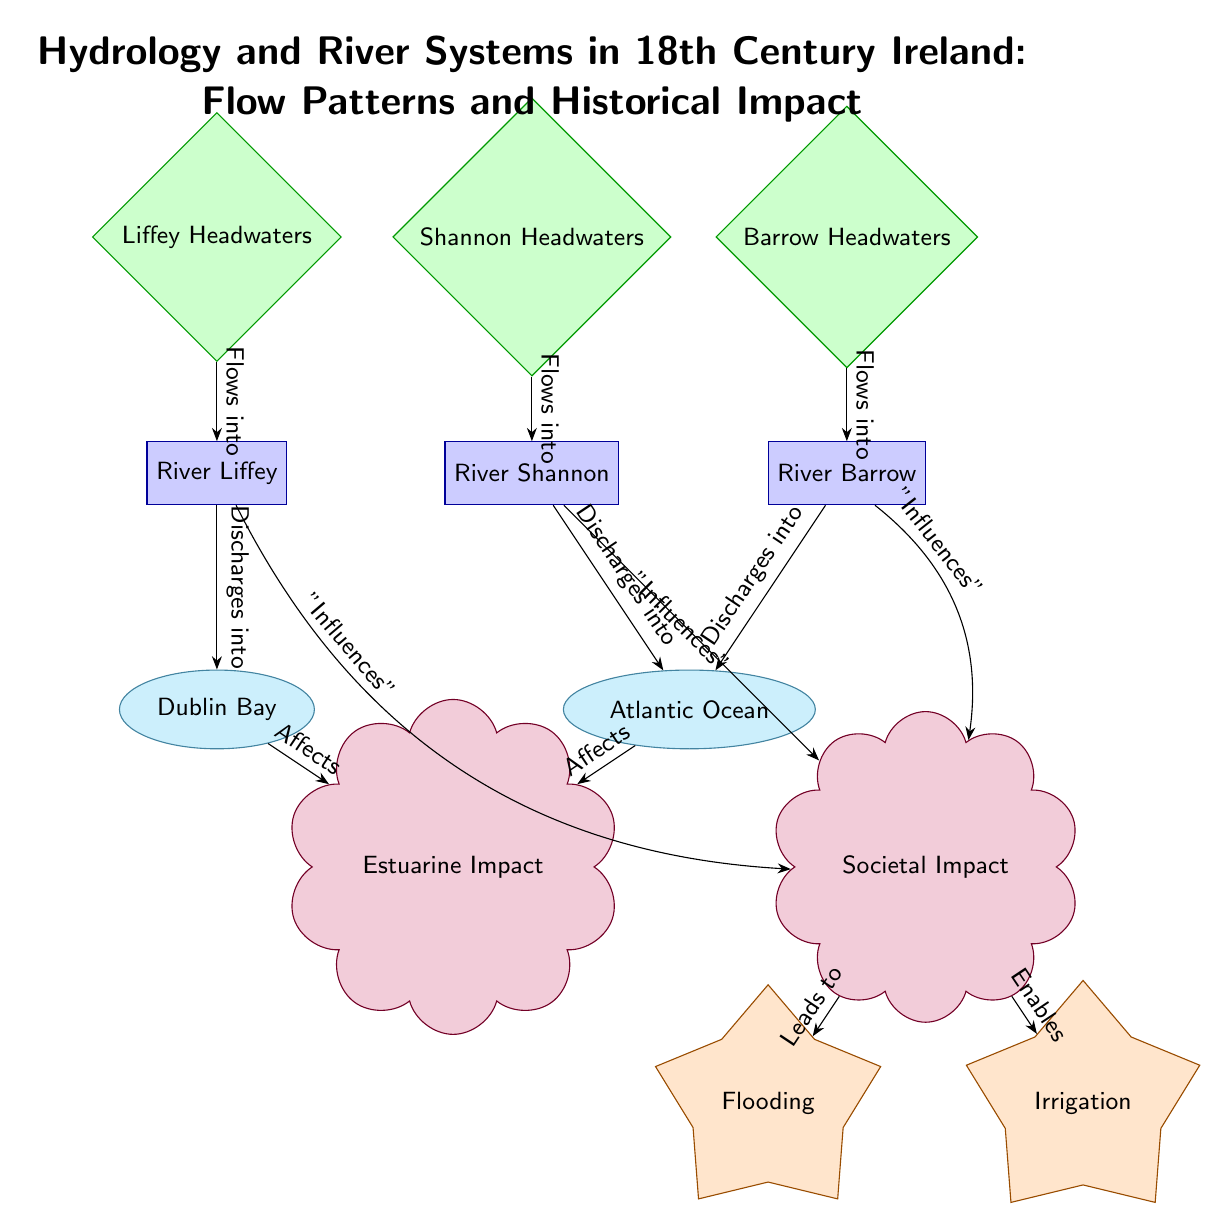What are the headwaters of the rivers depicted in the diagram? The diagram lists three headwaters: Liffey Headwaters, Shannon Headwaters, and Barrow Headwaters, which are shown as source nodes above the river nodes.
Answer: Liffey Headwaters, Shannon Headwaters, Barrow Headwaters How many rivers are included in the diagram? The diagram features three rivers: River Liffey, River Shannon, and River Barrow, indicated as river nodes.
Answer: Three Which outflow connects to Dublin Bay? The diagram shows that the River Liffey discharges into Dublin Bay, indicated by an edge pointing from Liffey River to Dublin Bay.
Answer: River Liffey What impact do the rivers have on society according to the diagram? The diagram illustrates that the rivers influence societal impact, as indicated by edges pointing towards the societal impact node and labeled "Influences."
Answer: Societal Impact How does societal impact lead to flooding? The diagram indicates that there is an edge leading from the societal impact node to the flooding phenomenon node, labeled "Leads to," which shows that societal impacts can result in flooding.
Answer: Leads to Which river discharges into the Atlantic Ocean? Both the River Shannon and River Barrow discharge into the Atlantic Ocean, as per the edges displaying this discharging relationship.
Answer: River Shannon, River Barrow What are the two identified phenomena related to the impacts in the diagram? The diagram mentions two phenomena resulting from societal impact: flooding and irrigation, shown as distinct nodes below societal impact.
Answer: Flooding, Irrigation Which body of water affects estuarine impact? The diagram illustrates that both Dublin Bay and the Atlantic Ocean affect estuarine impact, indicated by reciprocal edges pointing to the estuarine impact node.
Answer: Dublin Bay, Atlantic Ocean How many edges connect to societal impact? There are three edges connecting to societal impact: from the Liffey River, Shannon River, and Barrow River, collectively illustrating the influence of these rivers.
Answer: Three Which element in the diagram characterizes the influence on irrigation? The diagram clearly states that societal impacts enable irrigation, as seen by the edge connecting societal impact to irrigation, labeled "Enables."
Answer: Enables 